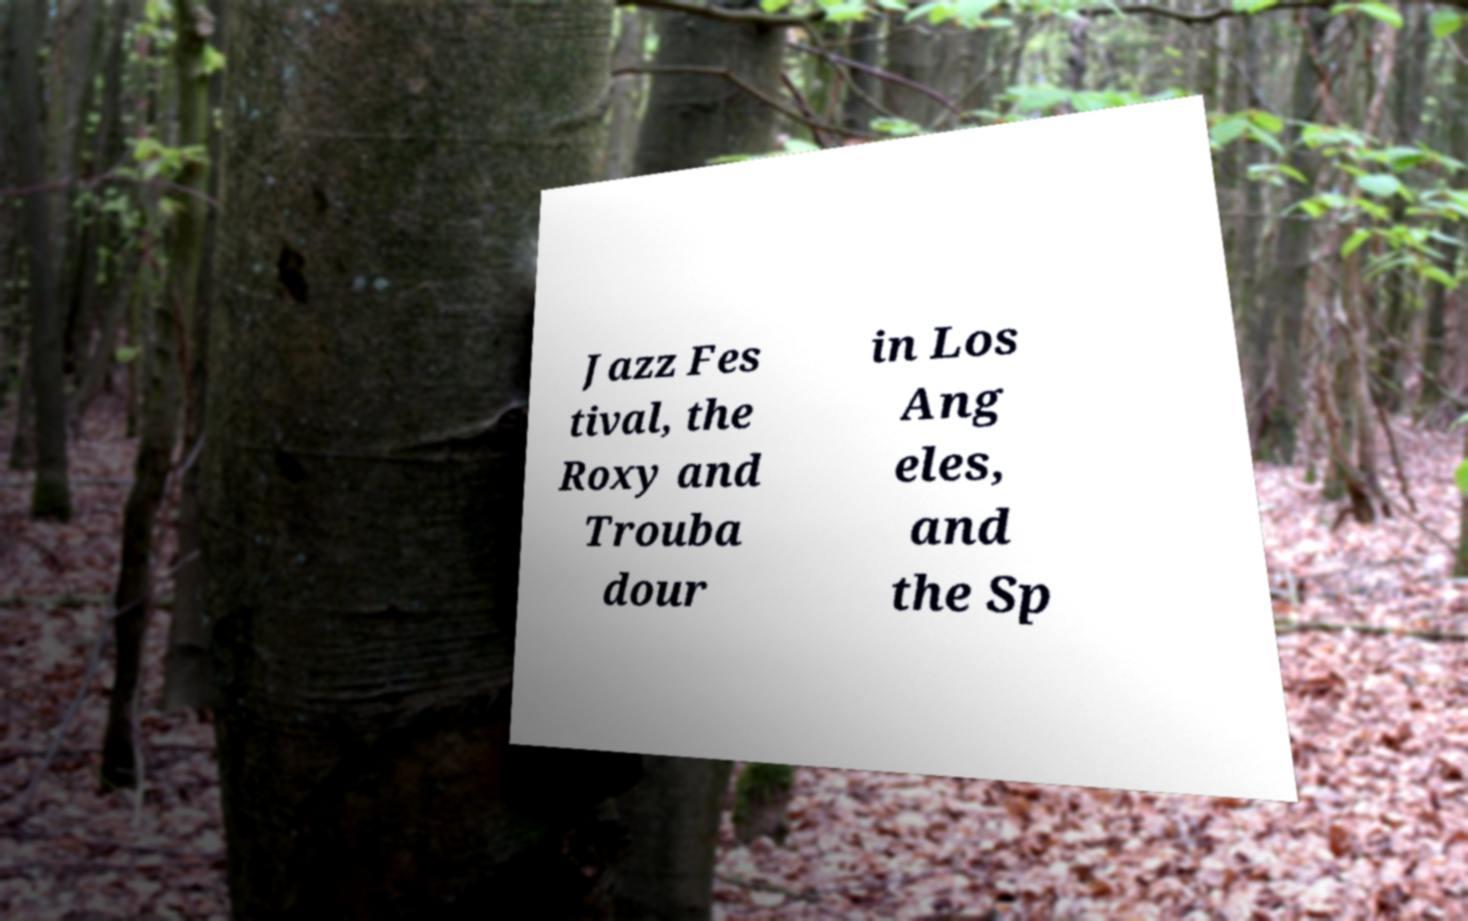Could you assist in decoding the text presented in this image and type it out clearly? Jazz Fes tival, the Roxy and Trouba dour in Los Ang eles, and the Sp 